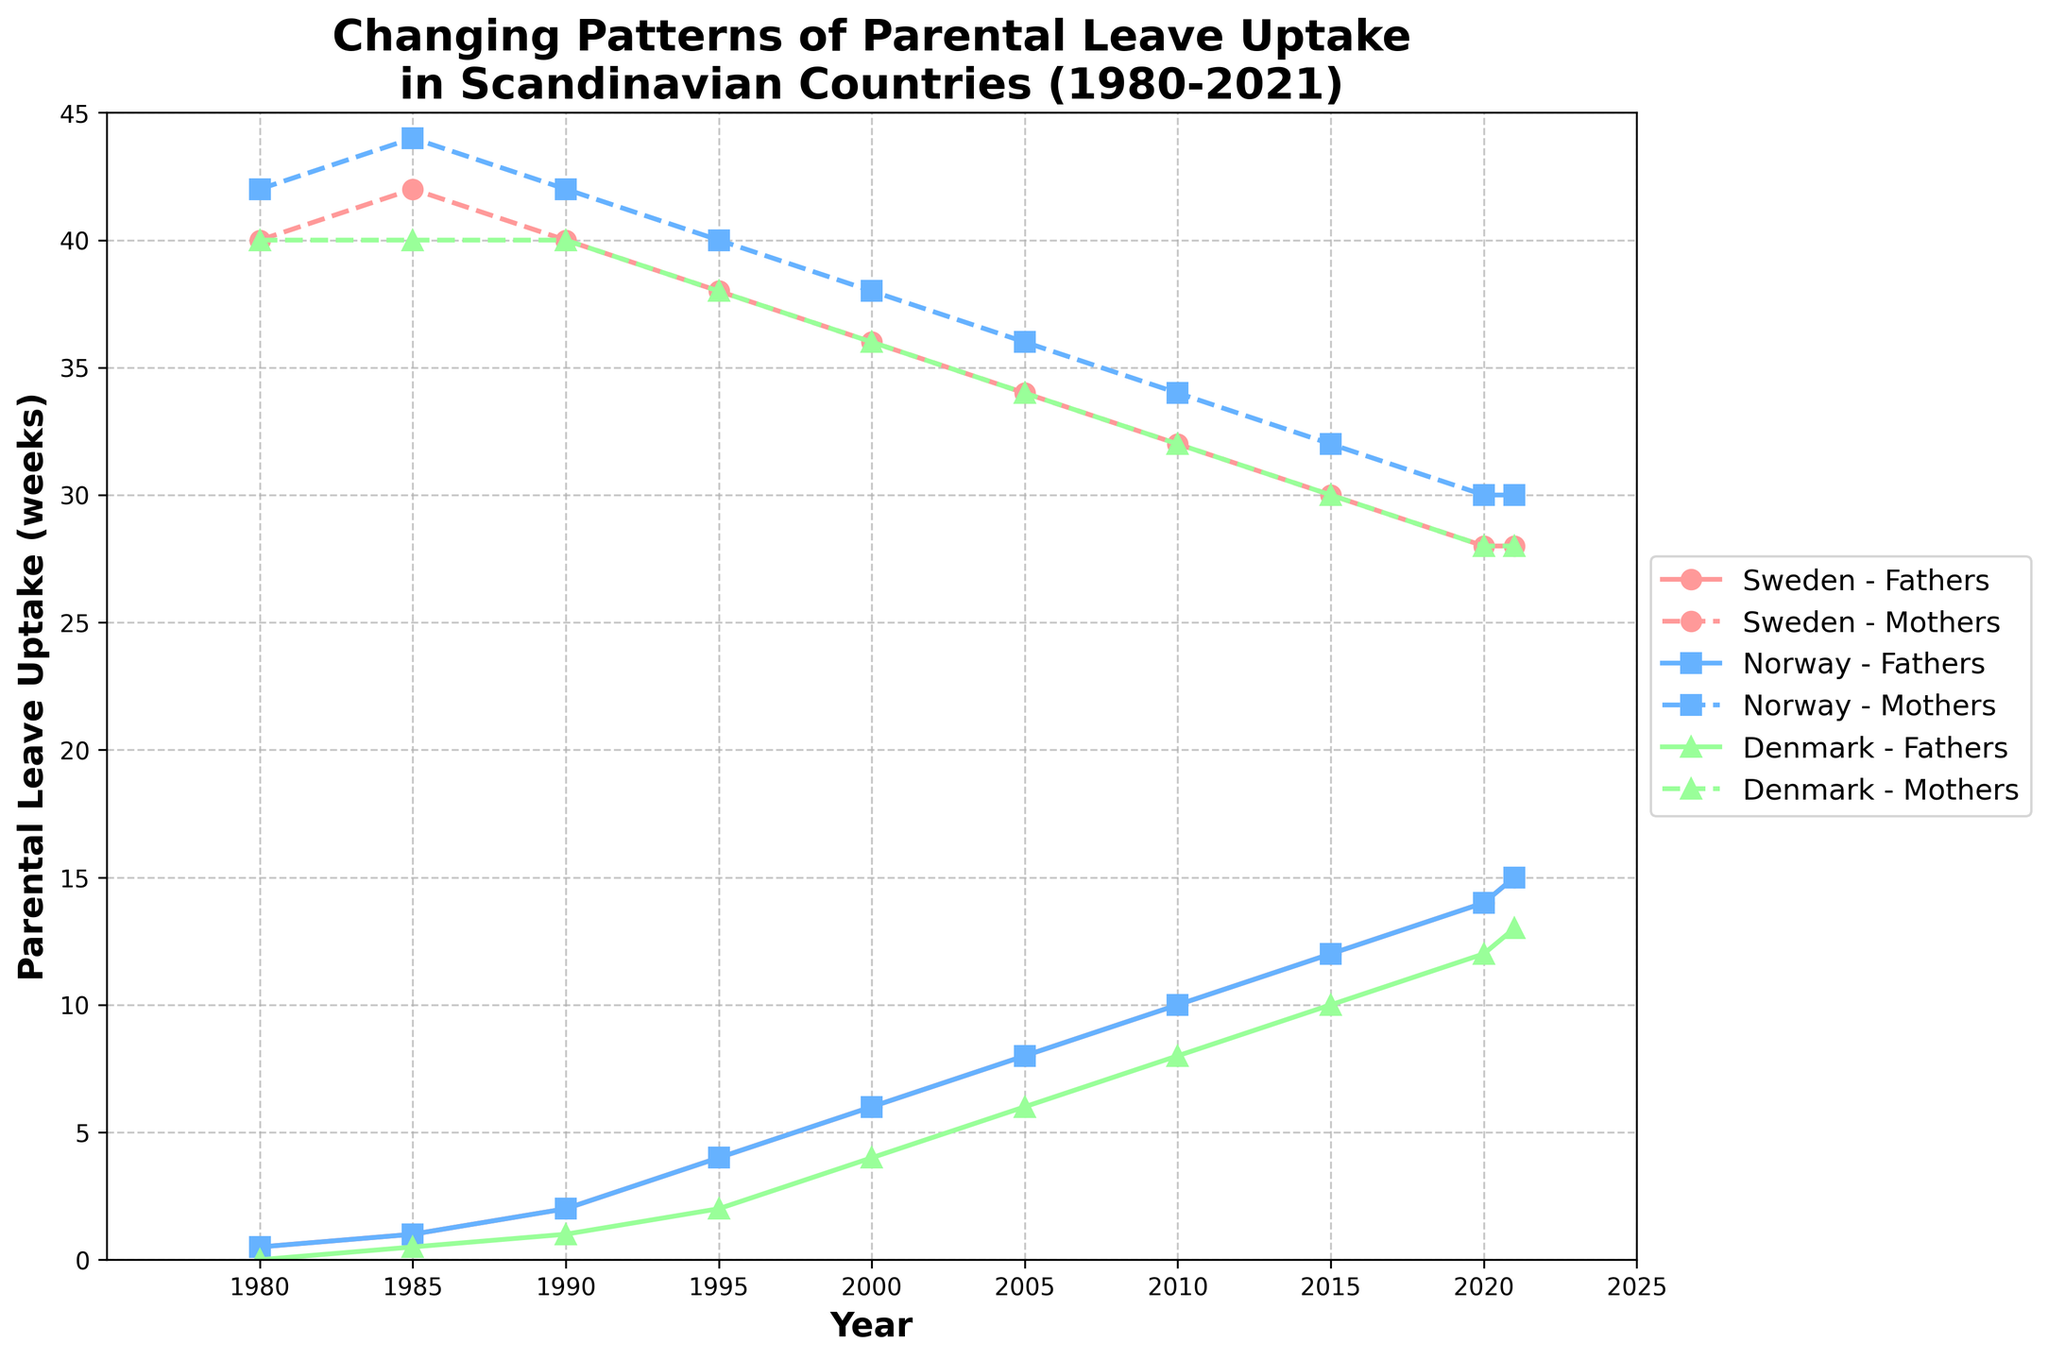how many weeks of parental leave did fathers in Denmark take in 1980? look at the plot line for Denmark in 1980 and trace it to the axis for fathers parental leave uptake
Answer: 0 weeks which country had the highest uptake of parental leave by mothers in 2005? the lines of mothers for the three countries and find the highest value in 2005.
Answer: norway did fathers in Sweden ever exceed 10 weeks of parental leave uptake before 2015? check the plot for Sweden line for fathers and look if it crosses 10 weeks before 2015
Answer: no what was the trend for mothers parental leave uptake in Norway from 1980 to 2021? trace the dashed line for Norway from 1980 to 2021 to note the overall pattern. [mothers uptake initially rose and then declined]
Answer: declined what is the difference in weeks between fathers and mothers parental leave uptake in Sweden in 1995? subtract parental leave uptake of fathers from mothers in 1995 for Sweden.
Answer: 34 weeks in which year did Denmark fathers first start taking more than 5 weeks of parental leave? check in Denmark plot for fathers first crosses 5 weeks threshold.
Answer: 2005 compare the uptake of parental leave by swedish fathers and mothers in 2010? note the difference by comparing 2010 data points for fathers and mothers for Sweden.
Answer: 22 weeks less for fathers how does parental leave uptake trend for danish fathers compare to danish mothers from 1980 to 2021? compare the trends of both Denmark lines, overall, mothers show minor variation while uptake by fathers increased steadily.
Answer: fathers' uptake increase when did norway mothers first show a decrease in weeks of parental leave uptake? check Norway mothers trend line for the first point it moves downward.
Answer: 2010 